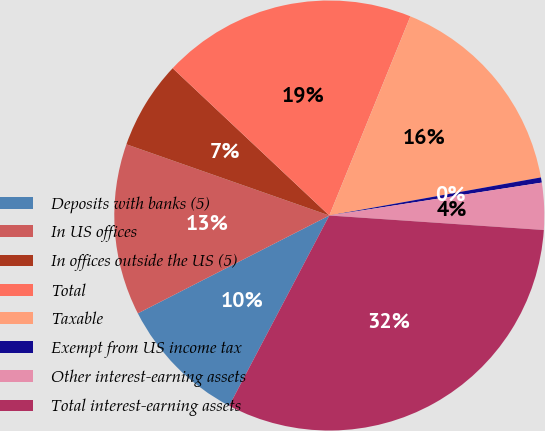Convert chart to OTSL. <chart><loc_0><loc_0><loc_500><loc_500><pie_chart><fcel>Deposits with banks (5)<fcel>In US offices<fcel>In offices outside the US (5)<fcel>Total<fcel>Taxable<fcel>Exempt from US income tax<fcel>Other interest-earning assets<fcel>Total interest-earning assets<nl><fcel>9.77%<fcel>12.89%<fcel>6.64%<fcel>19.14%<fcel>16.01%<fcel>0.39%<fcel>3.52%<fcel>31.63%<nl></chart> 